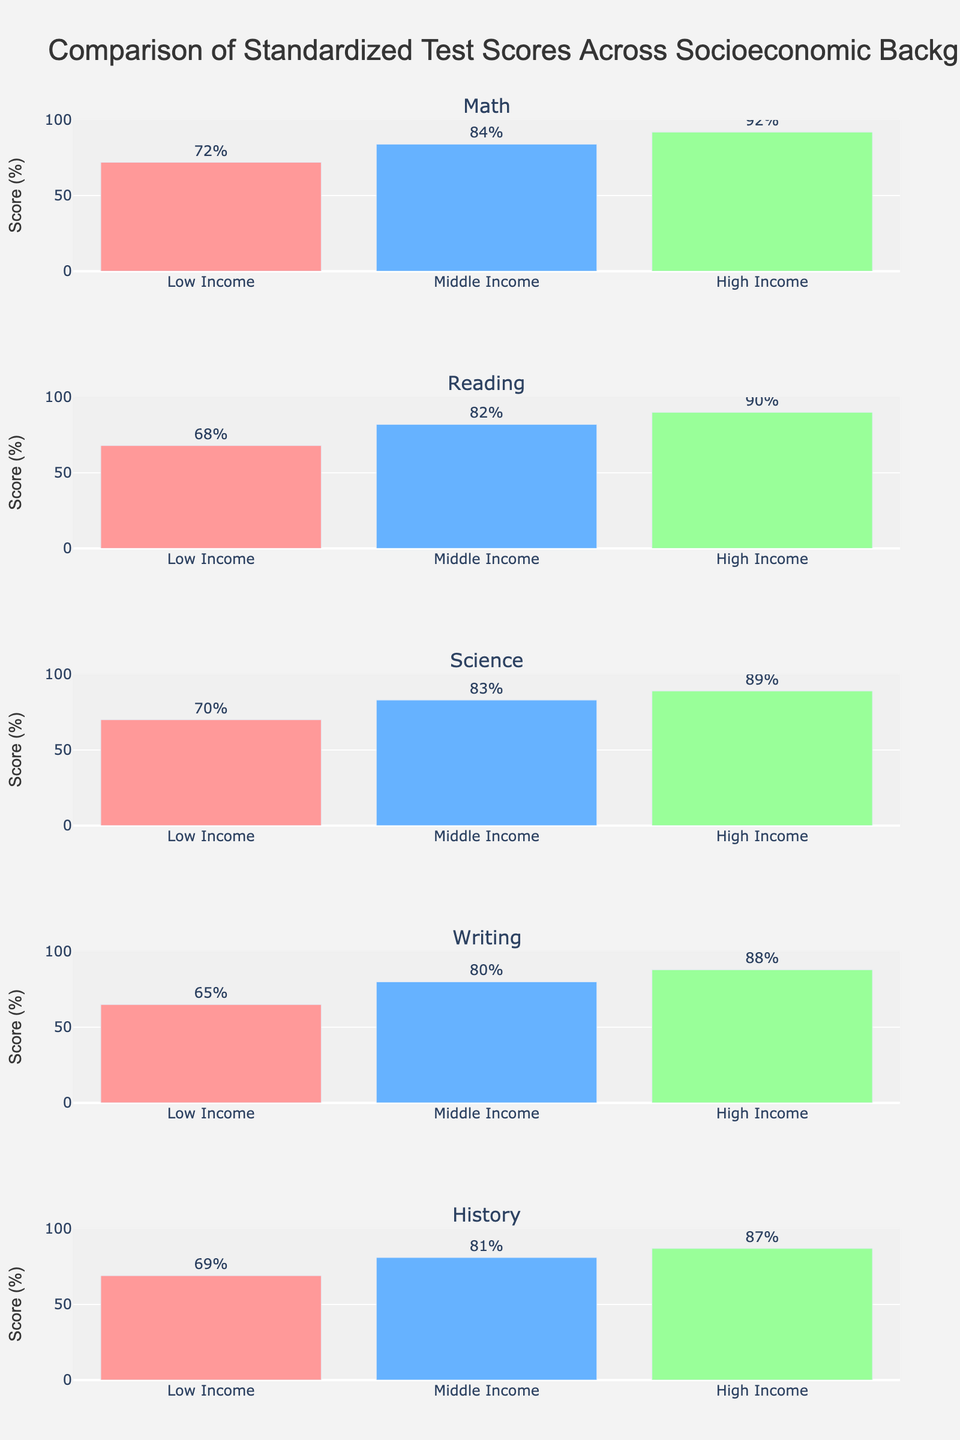What is the title of the figure? The title of the figure is usually displayed at the top center of the plot. By reading it directly from the figure, we can find the title.
Answer: "Comparison of Standardized Test Scores Across Socioeconomic Backgrounds" What is the highest score in the Math subject and which socioeconomic group achieved it? Look at the plot for Math and identify the highest bar. The group's name is present on the x-axis and the score is indicated by the height of the bar and the value displayed above it.
Answer: 92, High Income In Science, which income group has the lowest score, and what is that score? Look at the plot for Science and identify the shortest bar. The group's name is present on the x-axis and the score is indicated by the height of the bar and the value displayed above it.
Answer: Low Income, 70 